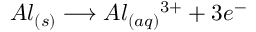Convert formula to latex. <formula><loc_0><loc_0><loc_500><loc_500>A l _ { ( s ) } \longrightarrow A l _ { ( a q ) } { ^ { 3 + } } + 3 e ^ { - }</formula> 